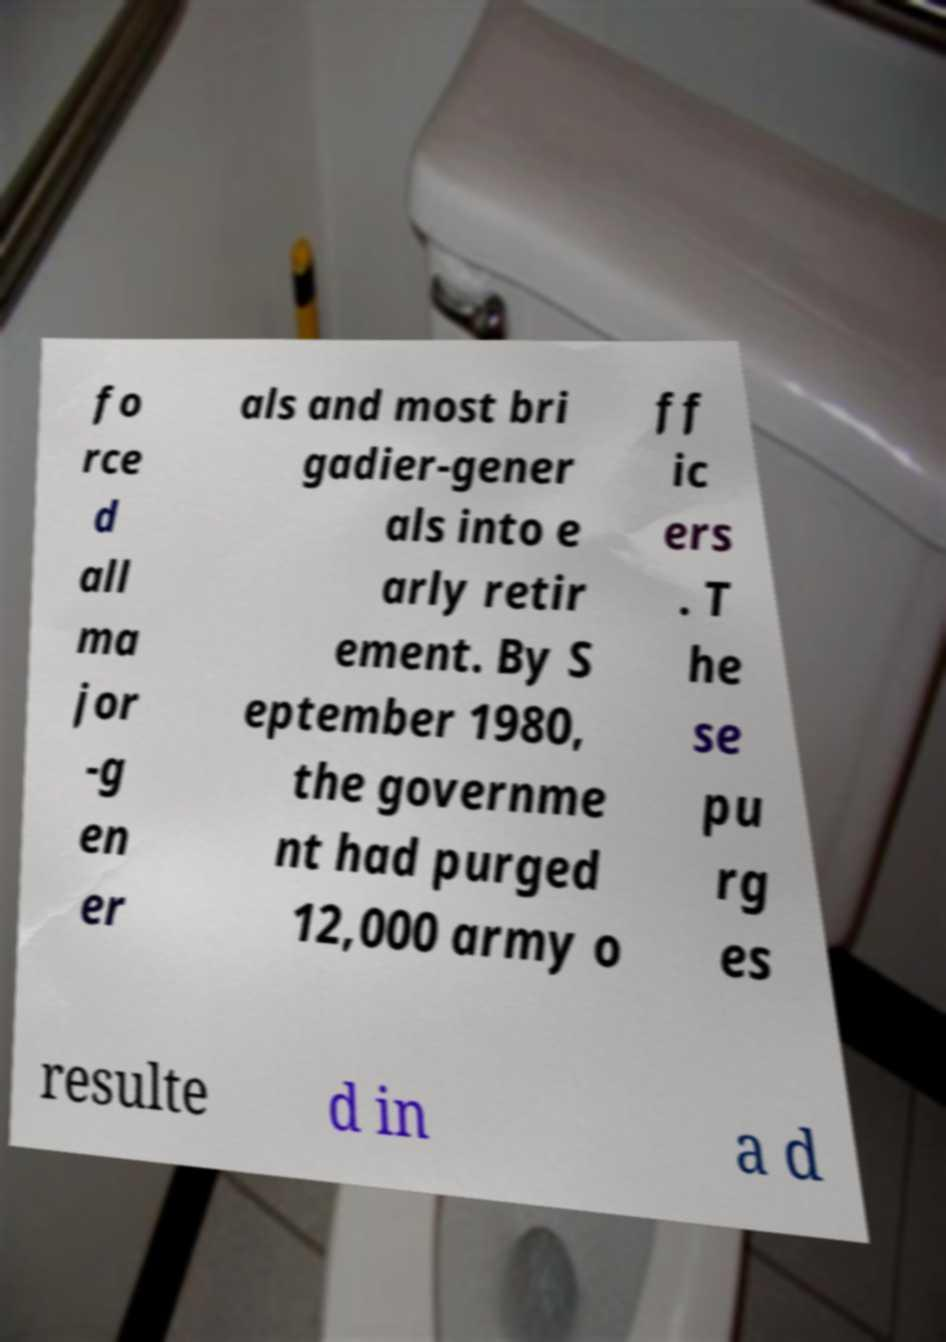For documentation purposes, I need the text within this image transcribed. Could you provide that? fo rce d all ma jor -g en er als and most bri gadier-gener als into e arly retir ement. By S eptember 1980, the governme nt had purged 12,000 army o ff ic ers . T he se pu rg es resulte d in a d 